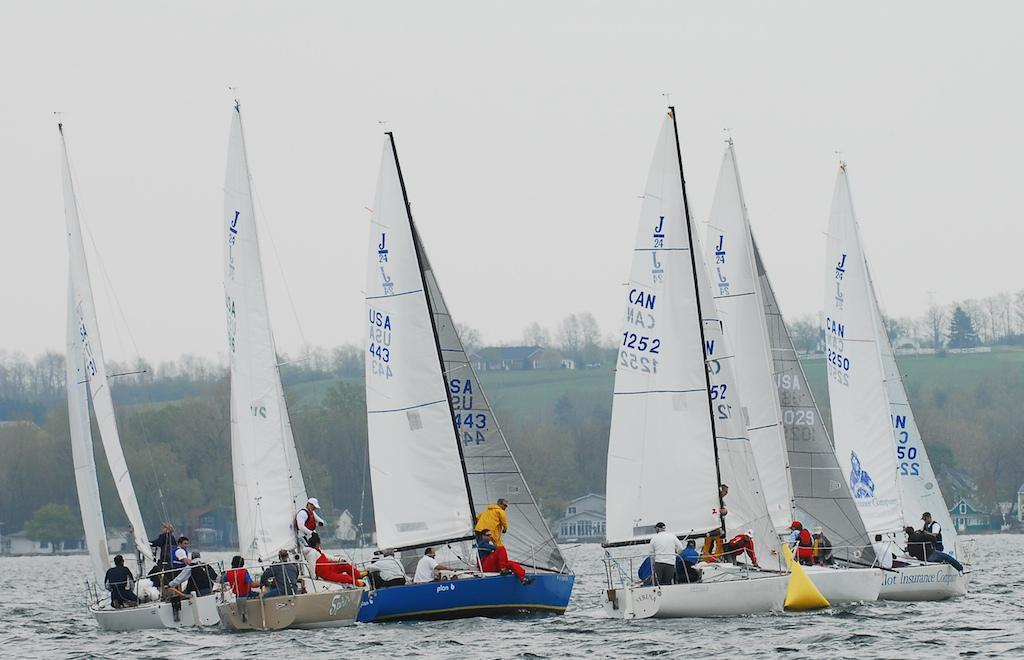<image>
Present a compact description of the photo's key features. Sailboats are out on the water with one boat identified on the sail by CAN 1252. 